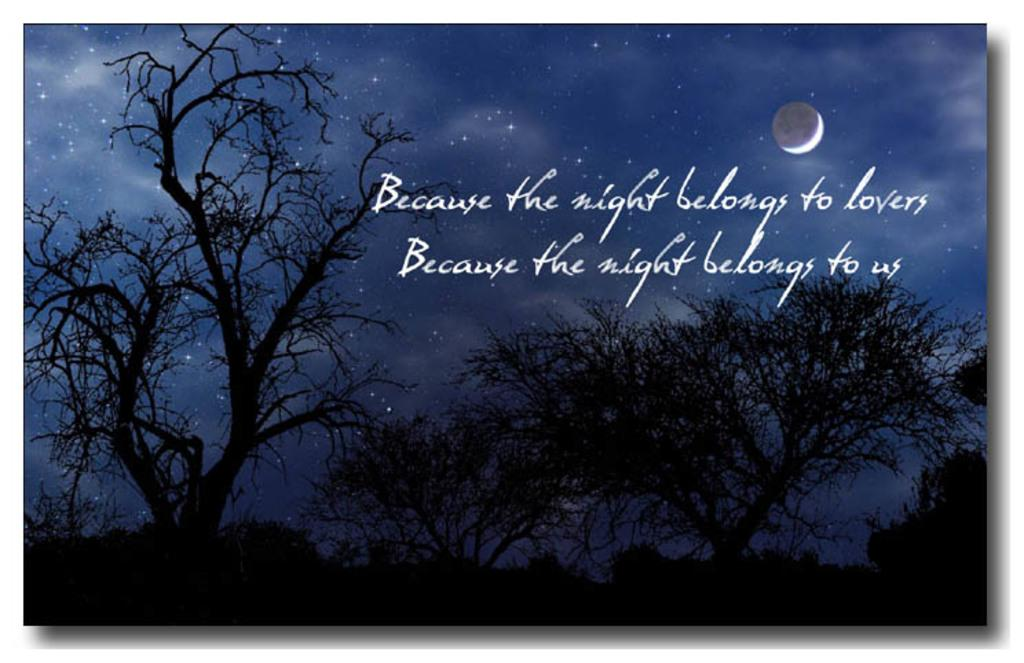What type of natural elements can be seen in the image? There are trees and the sky visible in the image. What celestial bodies are present in the image? Stars and the moon are visible in the image. How would you describe the lighting in the image? The image appears to be slightly dark. Is there any text or writing in the image? Yes, there is text or writing in the image. What is the price of the slip shown in the image? There is no slip present in the image, so it is not possible to determine its price. 